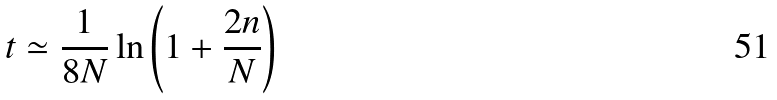Convert formula to latex. <formula><loc_0><loc_0><loc_500><loc_500>t \simeq \frac { 1 } { 8 N } \ln \left ( 1 + \frac { 2 n } { N } \right )</formula> 